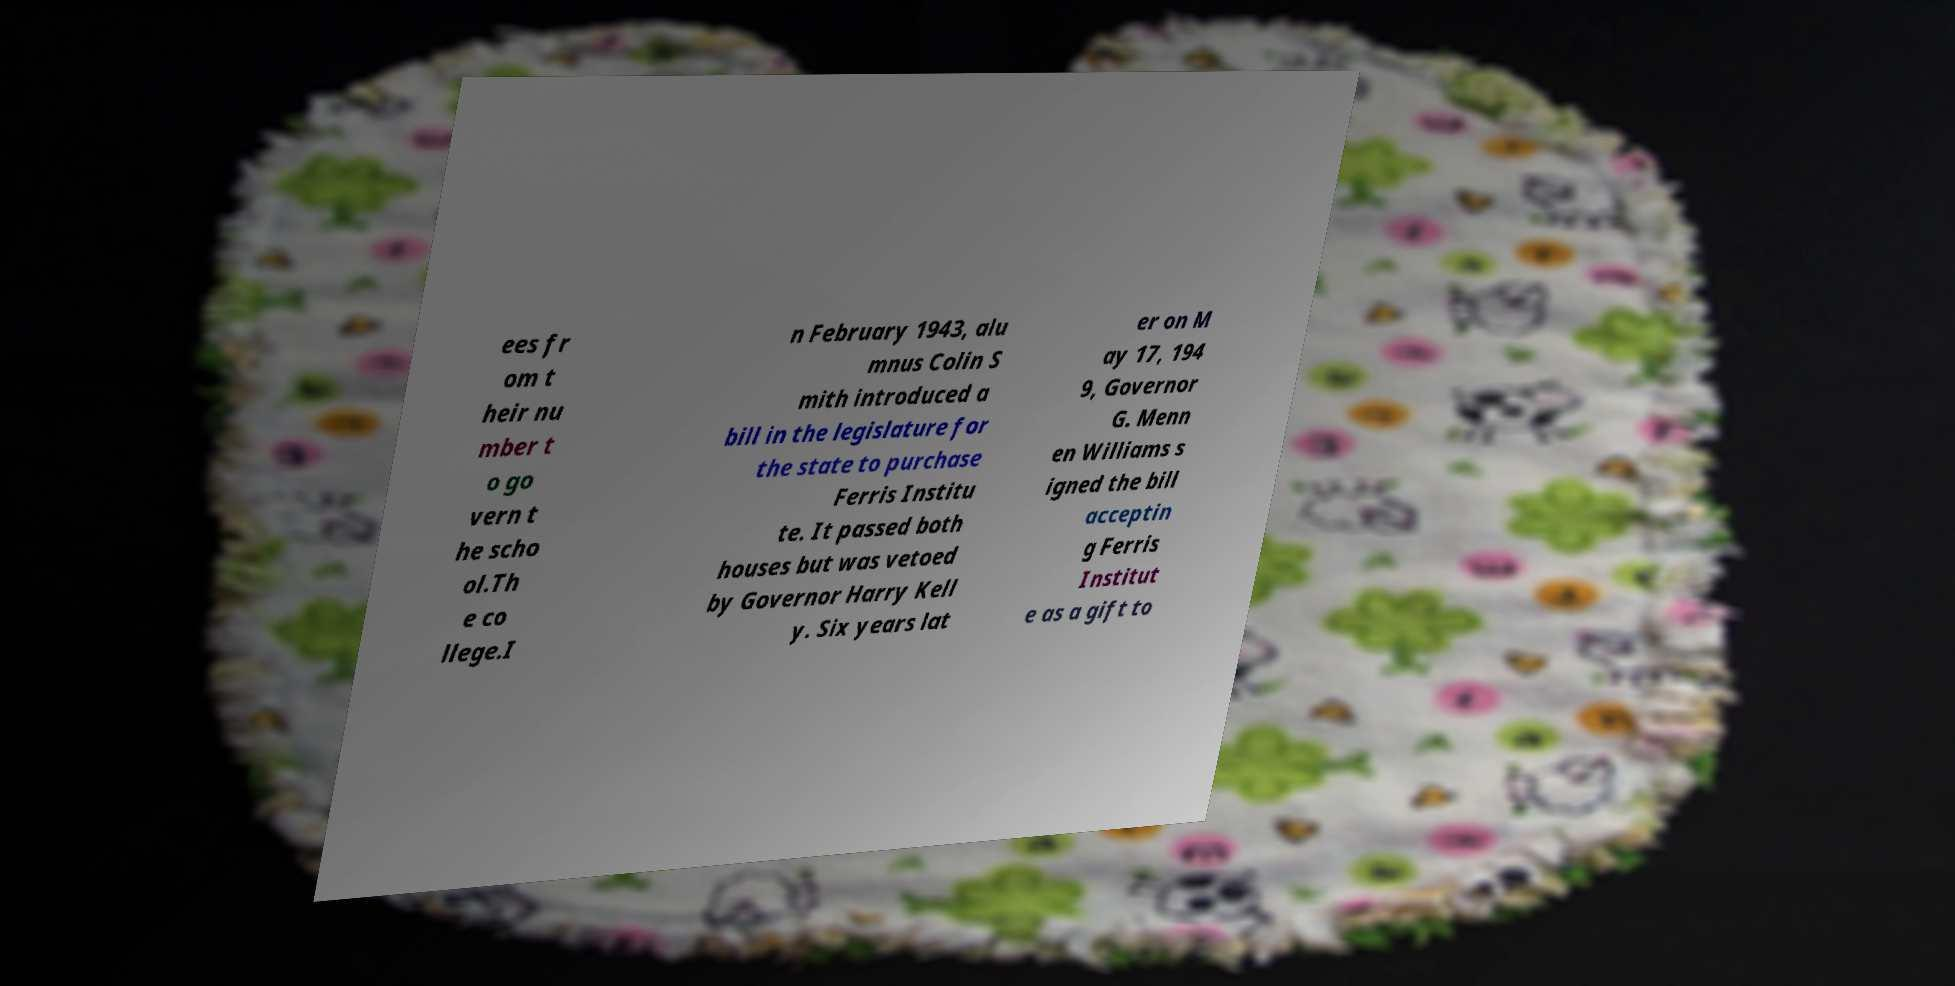Could you assist in decoding the text presented in this image and type it out clearly? ees fr om t heir nu mber t o go vern t he scho ol.Th e co llege.I n February 1943, alu mnus Colin S mith introduced a bill in the legislature for the state to purchase Ferris Institu te. It passed both houses but was vetoed by Governor Harry Kell y. Six years lat er on M ay 17, 194 9, Governor G. Menn en Williams s igned the bill acceptin g Ferris Institut e as a gift to 